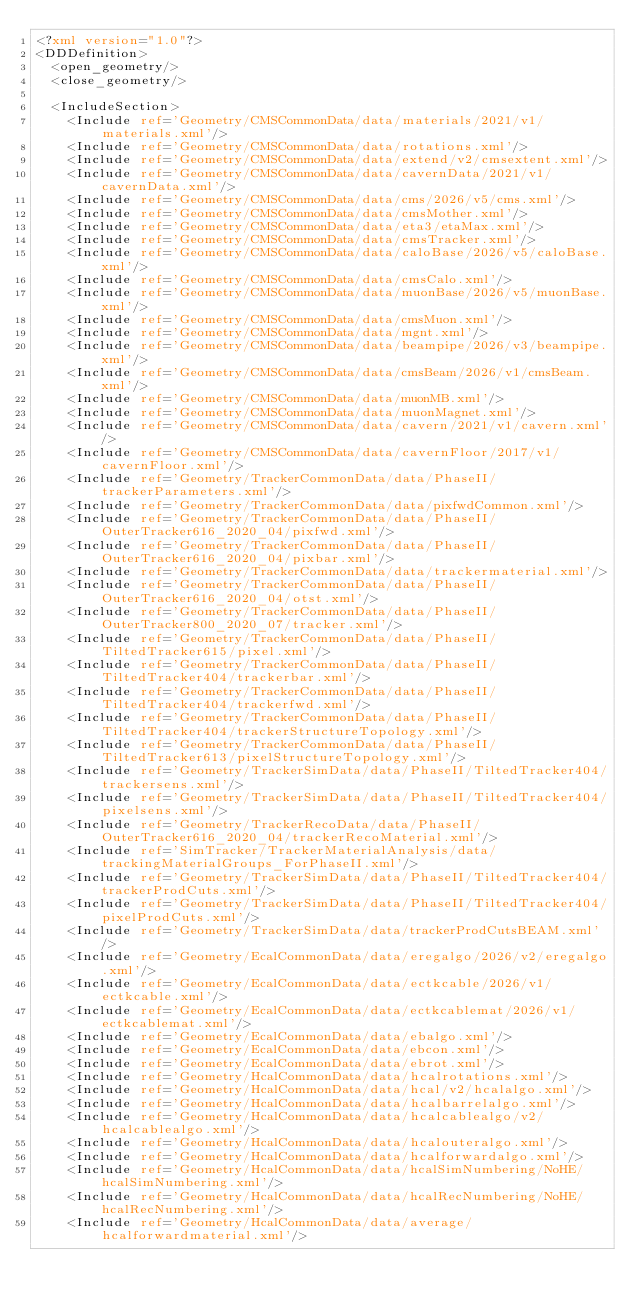Convert code to text. <code><loc_0><loc_0><loc_500><loc_500><_XML_><?xml version="1.0"?>
<DDDefinition>
  <open_geometry/>
  <close_geometry/>

  <IncludeSection>
    <Include ref='Geometry/CMSCommonData/data/materials/2021/v1/materials.xml'/>
    <Include ref='Geometry/CMSCommonData/data/rotations.xml'/>
    <Include ref='Geometry/CMSCommonData/data/extend/v2/cmsextent.xml'/>
    <Include ref='Geometry/CMSCommonData/data/cavernData/2021/v1/cavernData.xml'/>
    <Include ref='Geometry/CMSCommonData/data/cms/2026/v5/cms.xml'/>
    <Include ref='Geometry/CMSCommonData/data/cmsMother.xml'/>
    <Include ref='Geometry/CMSCommonData/data/eta3/etaMax.xml'/>
    <Include ref='Geometry/CMSCommonData/data/cmsTracker.xml'/>
    <Include ref='Geometry/CMSCommonData/data/caloBase/2026/v5/caloBase.xml'/>
    <Include ref='Geometry/CMSCommonData/data/cmsCalo.xml'/>
    <Include ref='Geometry/CMSCommonData/data/muonBase/2026/v5/muonBase.xml'/>
    <Include ref='Geometry/CMSCommonData/data/cmsMuon.xml'/>
    <Include ref='Geometry/CMSCommonData/data/mgnt.xml'/>
    <Include ref='Geometry/CMSCommonData/data/beampipe/2026/v3/beampipe.xml'/>
    <Include ref='Geometry/CMSCommonData/data/cmsBeam/2026/v1/cmsBeam.xml'/>
    <Include ref='Geometry/CMSCommonData/data/muonMB.xml'/>
    <Include ref='Geometry/CMSCommonData/data/muonMagnet.xml'/>
    <Include ref='Geometry/CMSCommonData/data/cavern/2021/v1/cavern.xml'/>
    <Include ref='Geometry/CMSCommonData/data/cavernFloor/2017/v1/cavernFloor.xml'/>
    <Include ref='Geometry/TrackerCommonData/data/PhaseII/trackerParameters.xml'/>
    <Include ref='Geometry/TrackerCommonData/data/pixfwdCommon.xml'/>
    <Include ref='Geometry/TrackerCommonData/data/PhaseII/OuterTracker616_2020_04/pixfwd.xml'/>
    <Include ref='Geometry/TrackerCommonData/data/PhaseII/OuterTracker616_2020_04/pixbar.xml'/>
    <Include ref='Geometry/TrackerCommonData/data/trackermaterial.xml'/>
    <Include ref='Geometry/TrackerCommonData/data/PhaseII/OuterTracker616_2020_04/otst.xml'/>
    <Include ref='Geometry/TrackerCommonData/data/PhaseII/OuterTracker800_2020_07/tracker.xml'/>
    <Include ref='Geometry/TrackerCommonData/data/PhaseII/TiltedTracker615/pixel.xml'/>
    <Include ref='Geometry/TrackerCommonData/data/PhaseII/TiltedTracker404/trackerbar.xml'/>
    <Include ref='Geometry/TrackerCommonData/data/PhaseII/TiltedTracker404/trackerfwd.xml'/>
    <Include ref='Geometry/TrackerCommonData/data/PhaseII/TiltedTracker404/trackerStructureTopology.xml'/>
    <Include ref='Geometry/TrackerCommonData/data/PhaseII/TiltedTracker613/pixelStructureTopology.xml'/>
    <Include ref='Geometry/TrackerSimData/data/PhaseII/TiltedTracker404/trackersens.xml'/>
    <Include ref='Geometry/TrackerSimData/data/PhaseII/TiltedTracker404/pixelsens.xml'/>
    <Include ref='Geometry/TrackerRecoData/data/PhaseII/OuterTracker616_2020_04/trackerRecoMaterial.xml'/>
    <Include ref='SimTracker/TrackerMaterialAnalysis/data/trackingMaterialGroups_ForPhaseII.xml'/>
    <Include ref='Geometry/TrackerSimData/data/PhaseII/TiltedTracker404/trackerProdCuts.xml'/>
    <Include ref='Geometry/TrackerSimData/data/PhaseII/TiltedTracker404/pixelProdCuts.xml'/>
    <Include ref='Geometry/TrackerSimData/data/trackerProdCutsBEAM.xml'/>
    <Include ref='Geometry/EcalCommonData/data/eregalgo/2026/v2/eregalgo.xml'/>
    <Include ref='Geometry/EcalCommonData/data/ectkcable/2026/v1/ectkcable.xml'/>
    <Include ref='Geometry/EcalCommonData/data/ectkcablemat/2026/v1/ectkcablemat.xml'/>
    <Include ref='Geometry/EcalCommonData/data/ebalgo.xml'/>
    <Include ref='Geometry/EcalCommonData/data/ebcon.xml'/>
    <Include ref='Geometry/EcalCommonData/data/ebrot.xml'/>
    <Include ref='Geometry/HcalCommonData/data/hcalrotations.xml'/>
    <Include ref='Geometry/HcalCommonData/data/hcal/v2/hcalalgo.xml'/>
    <Include ref='Geometry/HcalCommonData/data/hcalbarrelalgo.xml'/>
    <Include ref='Geometry/HcalCommonData/data/hcalcablealgo/v2/hcalcablealgo.xml'/>
    <Include ref='Geometry/HcalCommonData/data/hcalouteralgo.xml'/>
    <Include ref='Geometry/HcalCommonData/data/hcalforwardalgo.xml'/>
    <Include ref='Geometry/HcalCommonData/data/hcalSimNumbering/NoHE/hcalSimNumbering.xml'/>
    <Include ref='Geometry/HcalCommonData/data/hcalRecNumbering/NoHE/hcalRecNumbering.xml'/>
    <Include ref='Geometry/HcalCommonData/data/average/hcalforwardmaterial.xml'/></code> 